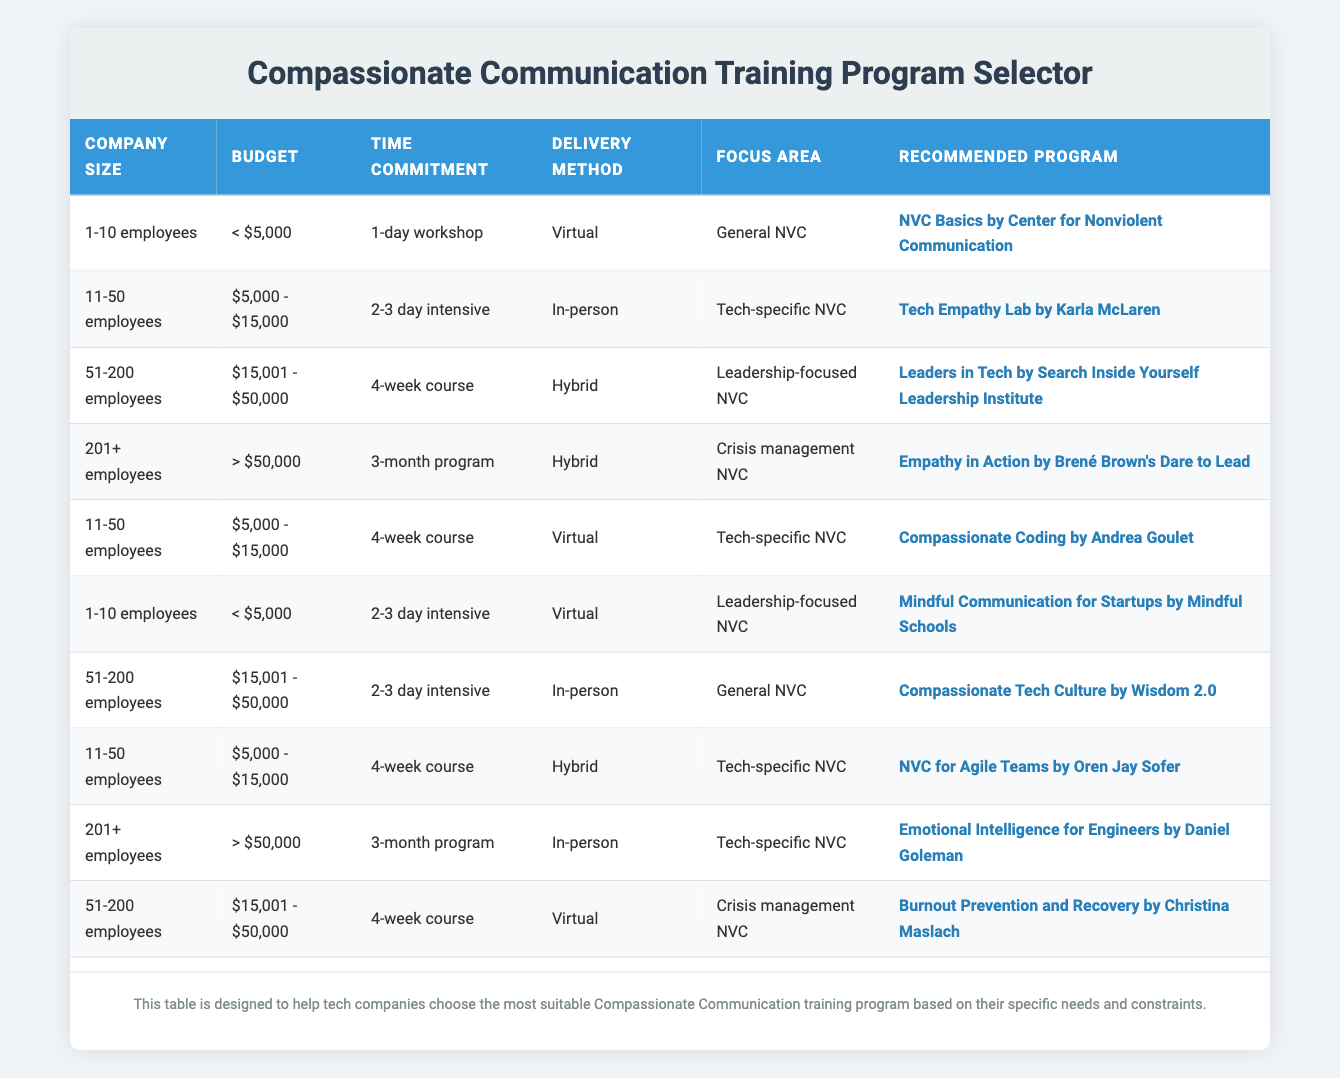What program is recommended for a company with 11-50 employees, a budget of $5,000 - $15,000, and a time commitment of a 2-3 day intensive? From the table, locate the row where the Company Size is "11-50 employees", Budget is "$5,000 - $15,000", and Time Commitment is "2-3 day intensive". This matches the second row, which recommends the "Tech Empathy Lab by Karla McLaren".
Answer: Tech Empathy Lab by Karla McLaren Is there a program recommended for 201+ employees with a budget of less than $5,000? Checking the table, there are no entries for companies with "201+ employees" having a budget of "< $5,000". Thus, the answer is no.
Answer: No What is the recommended program for companies with a budget greater than $50,000 and a focus area in crisis management NVC? In the table, look for rows that have the Budget as "> $50,000" and the Focus Area as "Crisis management NVC". There is no such row, so the answer is none.
Answer: None Which delivery method is associated with the "Leaders in Tech" program? To find this, locate the row in the table that lists the program "Leaders in Tech". This program is found in the third row, which indicates that the delivery method is "Hybrid".
Answer: Hybrid Which focus area has the most recommended programs listed in the table? Review each row and count the occurrences for each focus area. The focus areas are: "General NVC" (2), "Tech-specific NVC" (5), "Leadership-focused NVC" (3), and "Crisis management NVC" (2). The maximum is 5 for "Tech-specific NVC".
Answer: Tech-specific NVC What is the common time commitment for the recommended programs for companies with 51-200 employees and a budget between $15,001 and $50,000? Look for rows with "Company Size" as "51-200 employees" and "Budget" as "$15,001 - $50,000". The table shows two rows with this criteria, both indicating a "4-week course" as the time commitment.
Answer: 4-week course Is the "Empathy in Action" program suitable for a company with over 200 employees that has a time commitment of a 1-day workshop? Check the "Empathy in Action" program row: it applies to "201+ employees", but the time commitment listed is "3-month program", not a "1-day workshop". Therefore, the answer is no.
Answer: No If a startup with 1-10 employees chooses a virtual program, what is the highest budget they can allocate according to the table? Searching through the table for the "1-10 employees" category and "Virtual" delivery method, found the entries with budgets "< $5,000" and "< $15,000". The highest budget option available is "< $5,000".
Answer: < $5,000 